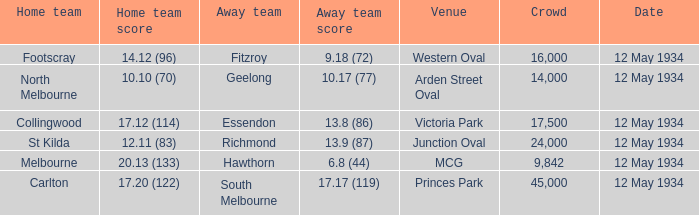What was the score of the away team while playing at the arden street oval? 10.17 (77). 